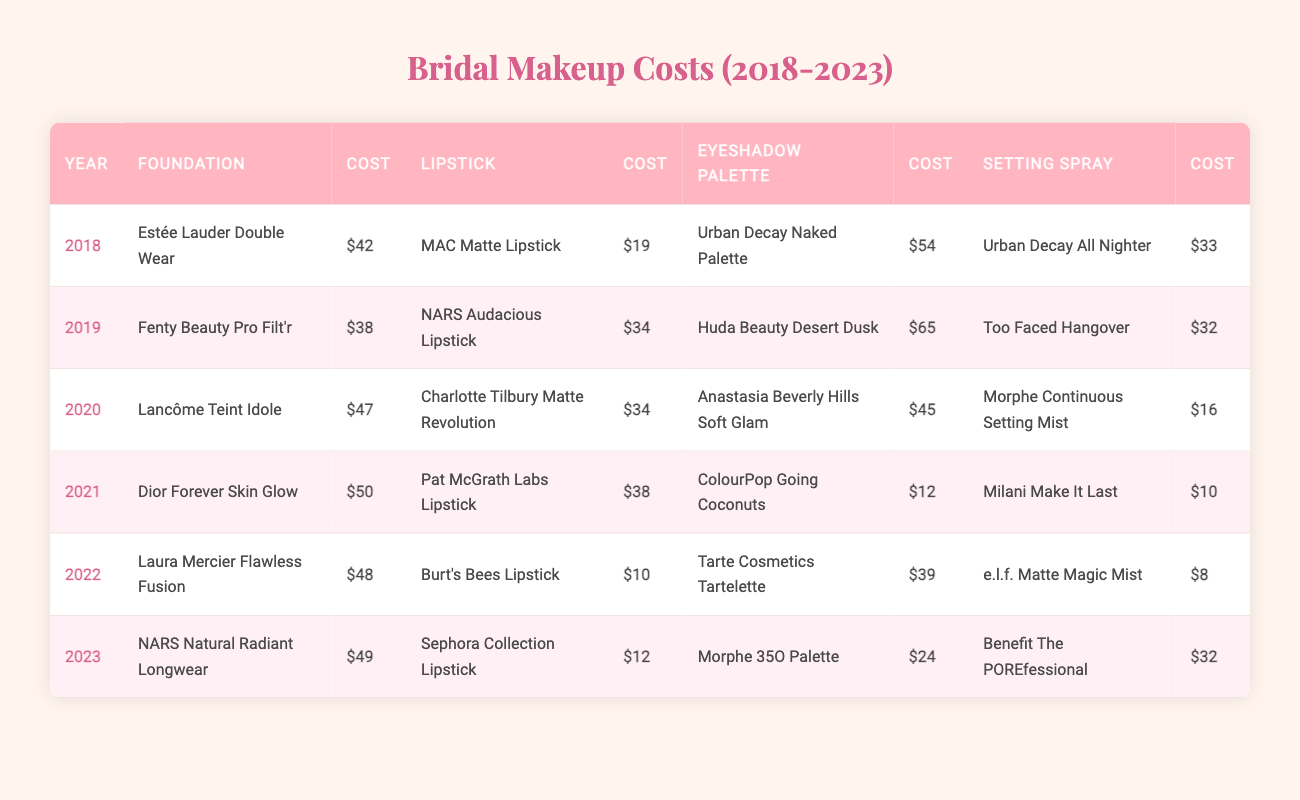What was the cost of foundation in 2020? In 2020, the foundation listed is Lancôme Teint Idole with a cost of $47.
Answer: $47 Which year had the most expensive eyeshadow palette? The eyeshadow palette in 2019 is the Huda Beauty Desert Dusk, costing $65, which is higher than all other years.
Answer: $65 What is the total cost of all bridal makeup supplies in 2021? In 2021, the costs are as follows: foundation $50, lipstick $38, eyeshadow $12, and setting spray $10. Adding these gives $50 + $38 + $12 + $10 = $110.
Answer: $110 Did the cost of lipstick increase from 2018 to 2019? In 2018, the lipstick cost was $19 (MAC Matte Lipstick) and in 2019 it was $34 (NARS Audacious Lipstick), indicating an increase of $15.
Answer: Yes What was the average cost of setting sprays from 2018 to 2023? The costs of setting sprays over these years are $33 (2018), $32 (2019), $16 (2020), $10 (2021), $8 (2022), and $32 (2023). The total cost is $33 + $32 + $16 + $10 + $8 + $32 = $131. There are 6 costs, therefore the average is $131 / 6 ≈ $21.83.
Answer: $21.83 Which foundation had the highest cost and in which year? The highest-cost foundation is Dior Forever Skin Glow at $50 in 2021.
Answer: $50 in 2021 Was the foundation cost in 2022 higher than in 2019? The foundation cost in 2022 is $48 (Laura Mercier Flawless Fusion), while in 2019 it was $38 (Fenty Beauty Pro Filt'r), indicating the 2022 cost is higher.
Answer: Yes What is the difference in cost between the cheapest and the most expensive lipsticks? The cheapest lipstick is Burt's Bees Lipstick at $10 in 2022, and the most expensive is NARS Audacious Lipstick at $34 in 2019. The difference is $34 - $10 = $24.
Answer: $24 